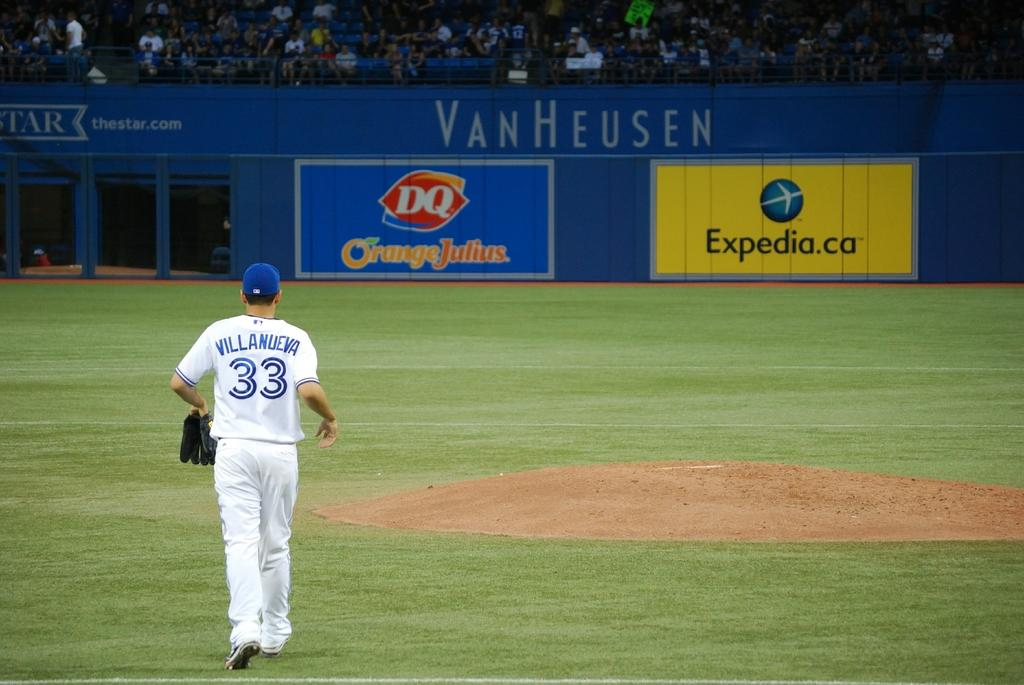<image>
Offer a succinct explanation of the picture presented. Baseball stadium with a blue wall that has VanHeusen at the top. 